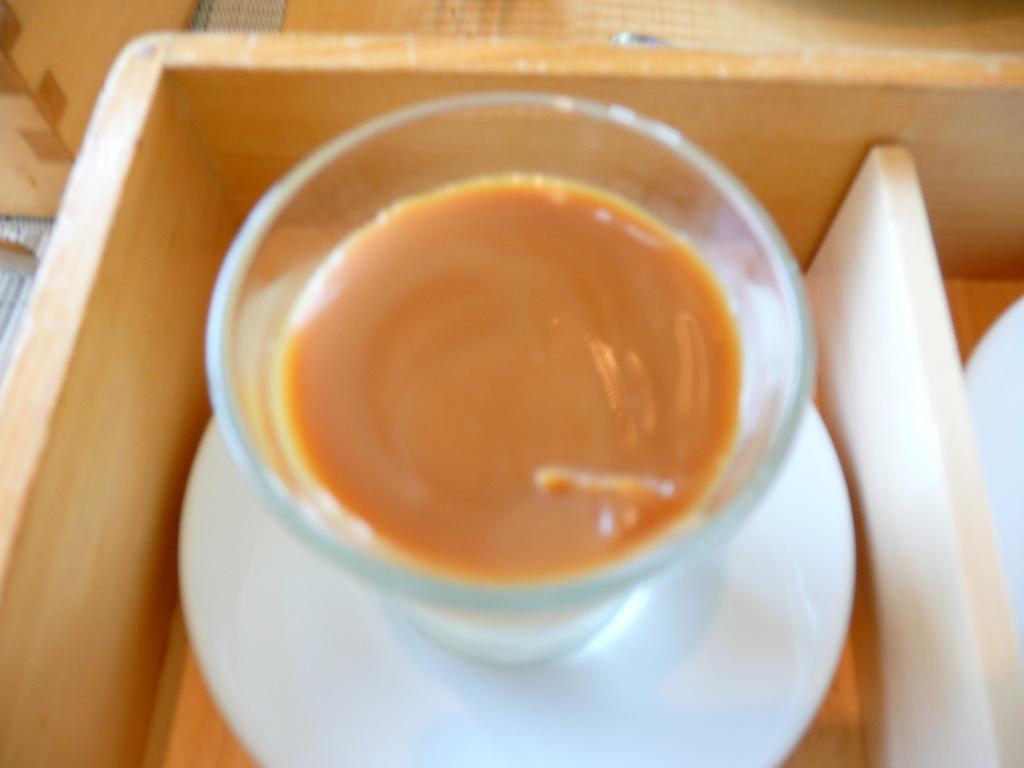In one or two sentences, can you explain what this image depicts? In this picture there is a glass of juice and a saucer. 